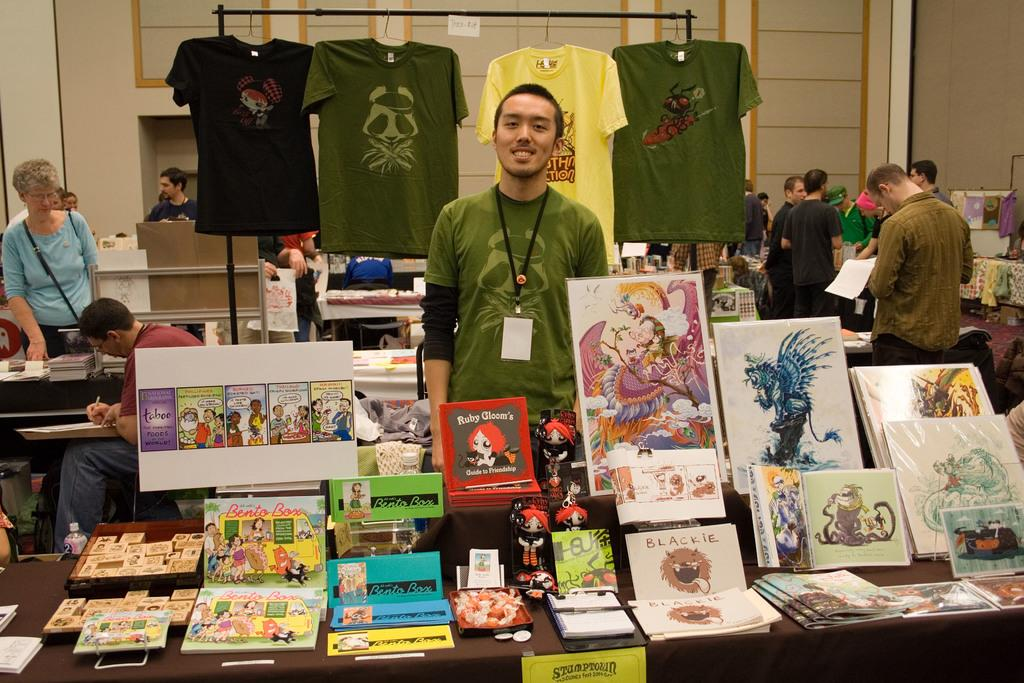<image>
Present a compact description of the photo's key features. Ruby Gloom's Guide to Friendship book sitting on a table. 